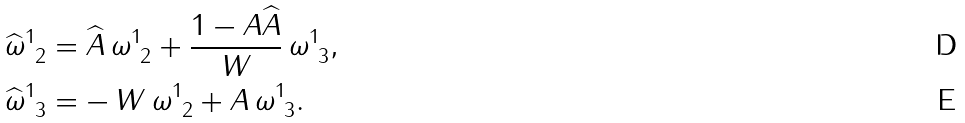Convert formula to latex. <formula><loc_0><loc_0><loc_500><loc_500>\widehat { \omega } ^ { 1 } _ { \ 2 } & = \widehat { A } \, \omega ^ { 1 } _ { \ 2 } + \frac { 1 - A \widehat { A } } { W } \, \omega ^ { 1 } _ { \ 3 } , \\ \widehat { \omega } ^ { 1 } _ { \ 3 } & = - \, W \, \omega ^ { 1 } _ { \ 2 } + A \, \omega ^ { 1 } _ { \ 3 } .</formula> 